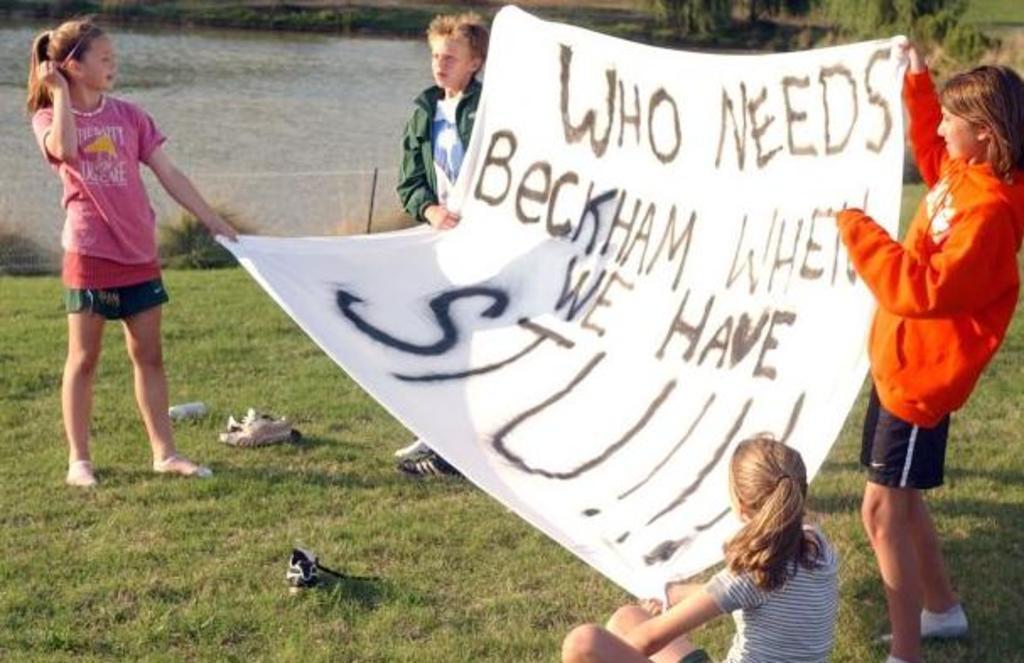Could you give a brief overview of what you see in this image? In this image there are four children holding a banner, there is grass, there is plant, there is a lake. 